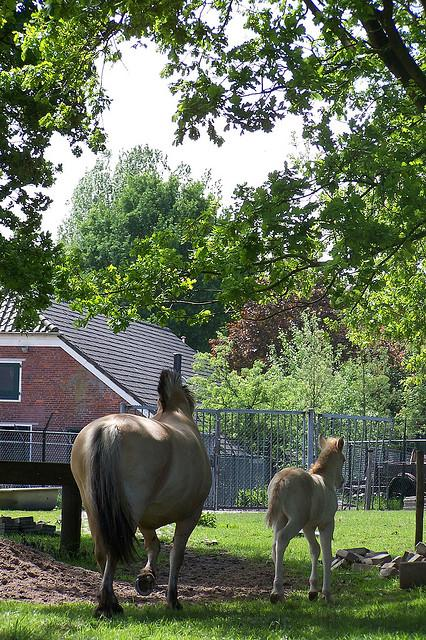What are the horses doing? Please explain your reasoning. standing. The horses are standing in the grass. 